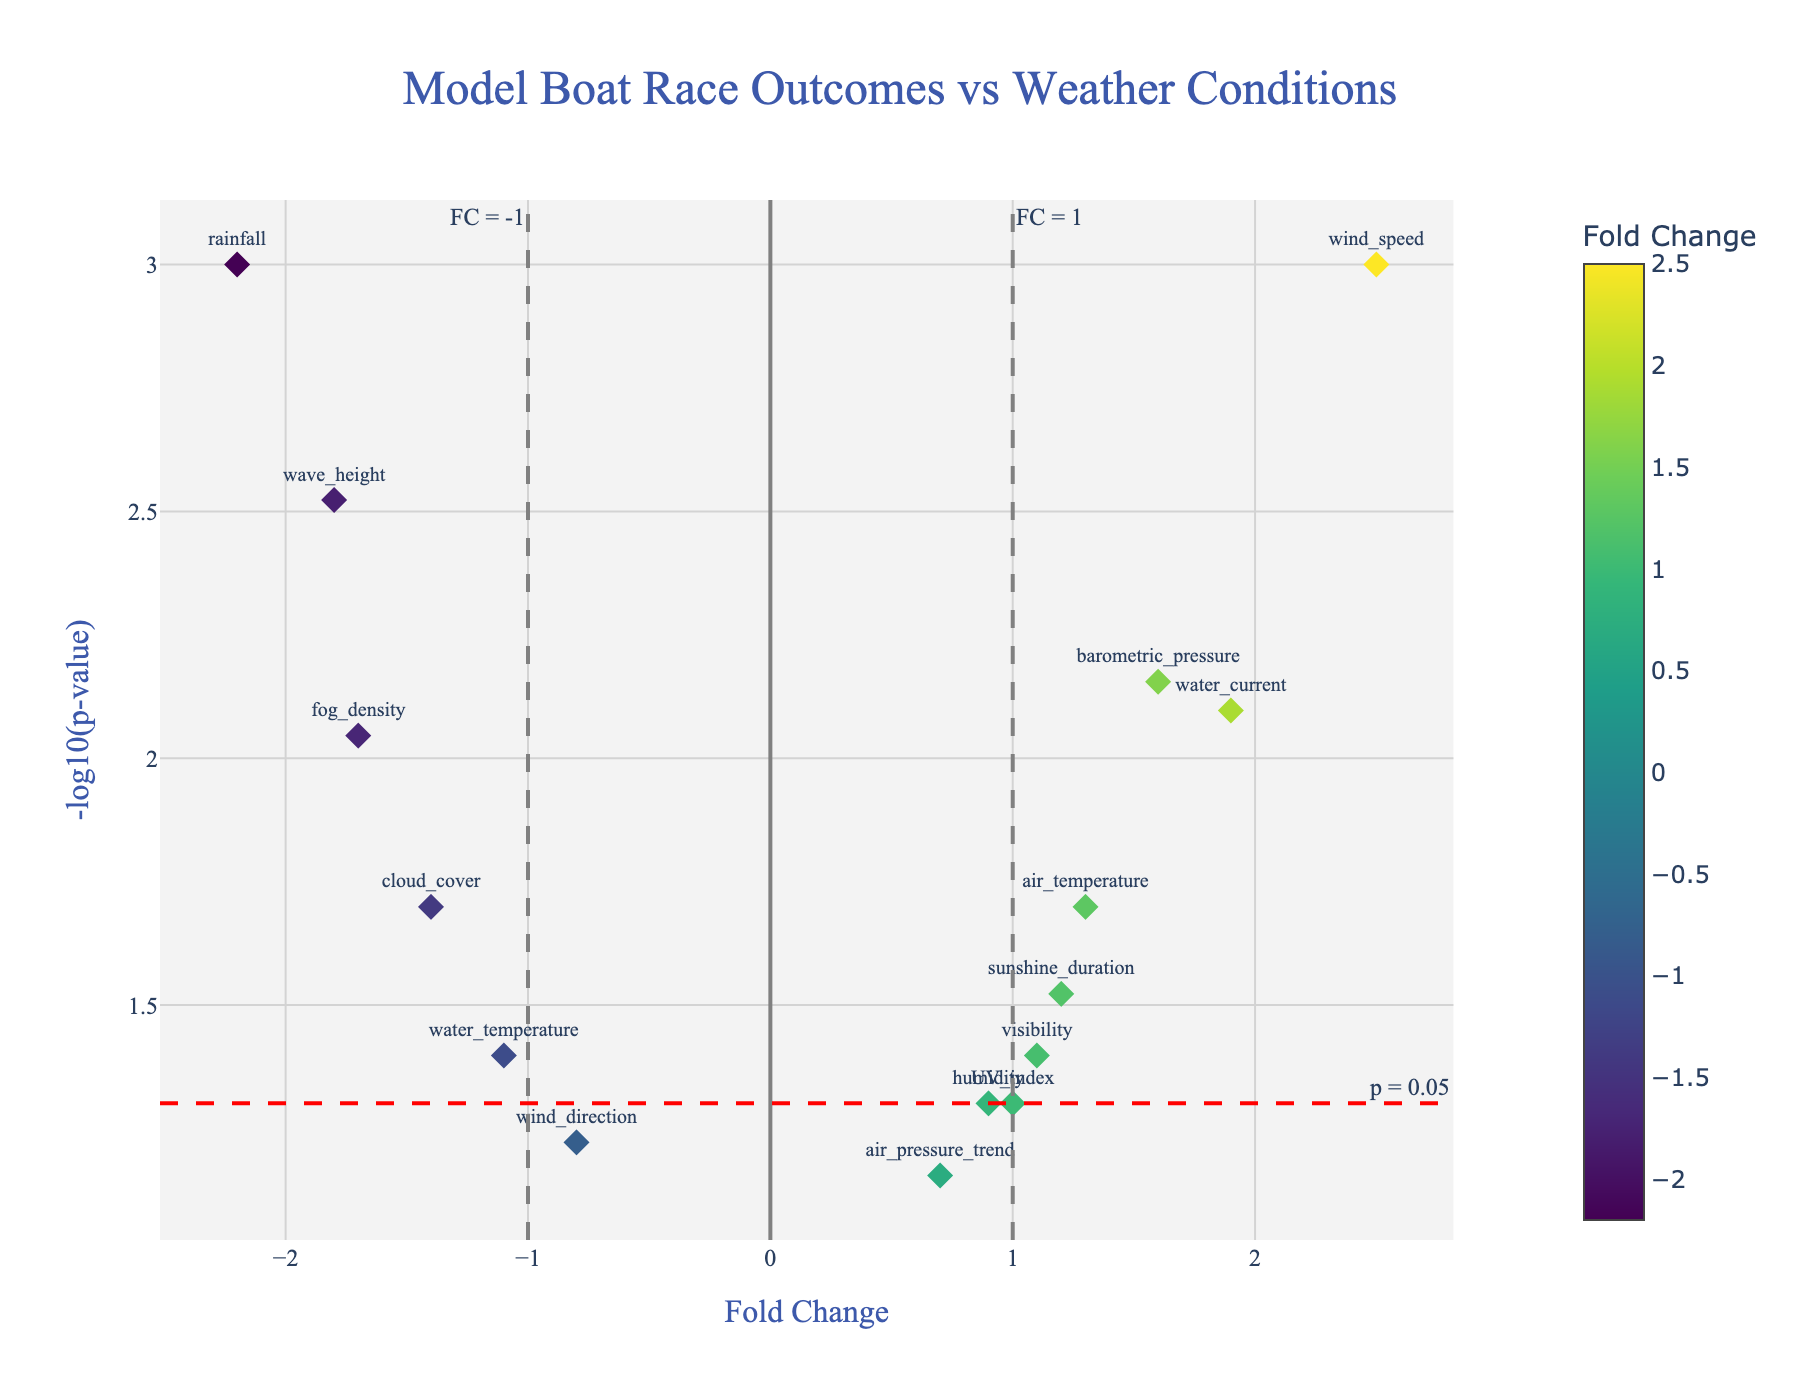What is the title of the plot? The title of the plot is usually displayed at the top of the figure and provides a summary of what the plot represents. By looking at the top of the plot, you can see the title "Model Boat Race Outcomes vs Weather Conditions".
Answer: Model Boat Race Outcomes vs Weather Conditions How many race conditions have a p-value less than 0.01? To find the number of race conditions with a p-value less than 0.01, identify data points on the plot where the y-axis value (-log10(p-value)) is greater than 2 (since -log10(0.01) = 2). These conditions include wind speed, wave height, barometric pressure, rainfall, water current, and fog density.
Answer: 6 Which race condition has the highest fold change? The race condition with the highest fold change is the one farthest to the right on the x-axis. By looking at the plot, you can see that "wind speed" is the farthest to the right with a fold change of 2.5.
Answer: wind speed Which race condition has the lowest fold change? The race condition with the lowest fold change is the one farthest to the left on the x-axis. By looking at the plot, "rainfall" is the farthest to the left with a fold change of -2.2.
Answer: rainfall What p-value threshold line is indicated on the plot? The p-value threshold line is usually indicated to highlight the significance level. By observing the plot, there is a horizontal dashed line with an annotation "p = 0.05". This corresponds to -log10(0.05) ≈ 1.3.
Answer: p = 0.05 How many race conditions show a significant effect (p-value < 0.05) and a positive fold change? To determine this, count the data points positioned above the p = 0.05 horizontal line (y > 1.3) and right of the vertical dashed line at FC = 1. These include wind speed, barometric pressure, and water current (3 conditions).
Answer: 3 Which race condition has the closest p-value to the significance threshold (p = 0.05) and a positive fold change? Find the data point closest to y = 1.3 on the plot with a positive fold change. "humidity" is closest to the threshold with a positive fold change.
Answer: humidity Which race conditions are labeled with a negative fold change and significant p-value? Negative fold change values are to the left of x = 0; significant p-values fall above y = 1.3 (-log10(0.05)). These conditions include wave height, rainfall, fog density, and cloud cover.
Answer: wave height, rainfall, fog density, cloud cover What are the fold change and p-value for cloud cover? Identify the specific data point labeled "cloud cover". From the hover text in the plot or knowing the data, it has a fold change of -1.4 and p-value of 0.02 (-log10(p-value) ≈ 1.7).
Answer: -1.4 and 0.02 